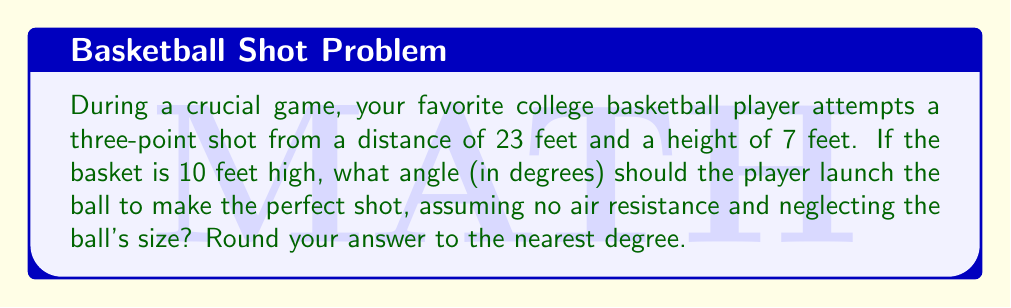Could you help me with this problem? Let's approach this step-by-step using trigonometry:

1) First, let's visualize the problem:

[asy]
unitsize(10pt);
draw((0,0)--(23,0)--(23,10)--(0,10)--cycle);
draw((0,7)--(23,10));
label("23 ft", (11.5,0), S);
label("10 ft", (23,5), E);
label("7 ft", (0,3.5), W);
label("θ", (1,7.5), NW);
dot((0,7));
dot((23,10));
[/asy]

2) We can treat this as a right triangle problem. The horizontal distance is 23 feet, and the vertical distance the ball needs to travel is 3 feet (10 ft - 7 ft).

3) We need to find the angle θ at which the ball should be launched. This forms the angle of elevation from the horizontal.

4) In this right triangle:
   - The adjacent side is 23 feet
   - The opposite side is 3 feet

5) We can use the arctangent function to find this angle:

   $$θ = \tan^{-1}(\frac{\text{opposite}}{\text{adjacent}}) = \tan^{-1}(\frac{3}{23})$$

6) Using a calculator or computer:

   $$θ = \tan^{-1}(\frac{3}{23}) \approx 7.44°$$

7) Rounding to the nearest degree:

   $$θ \approx 7°$$
Answer: $7°$ 